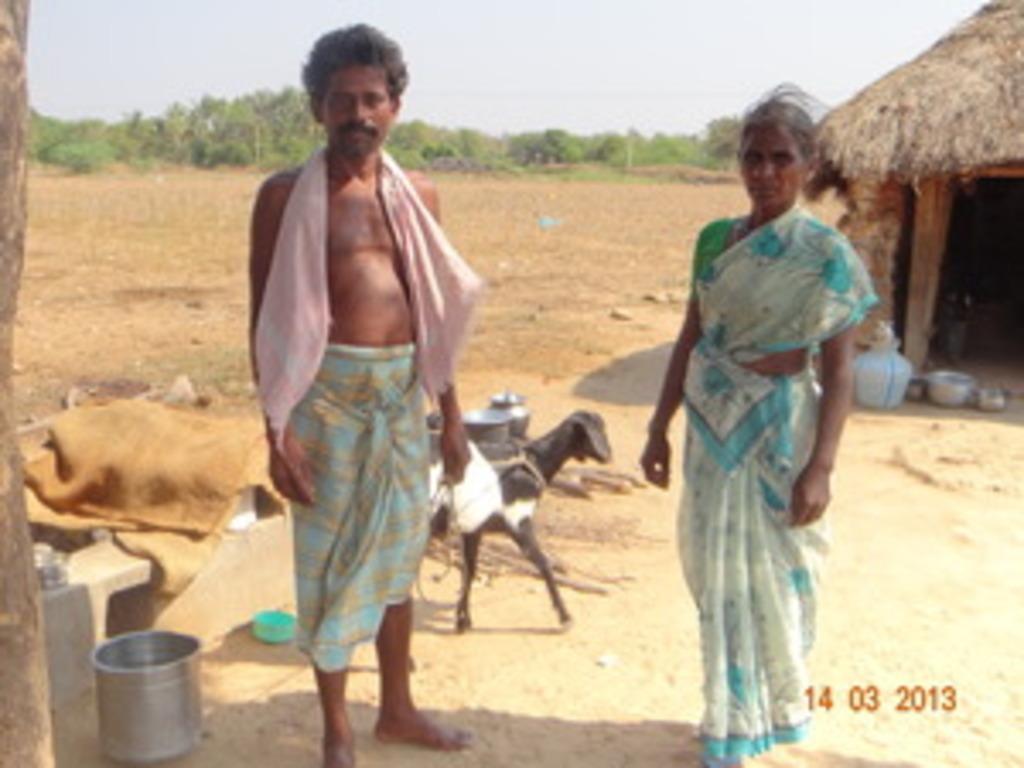Describe this image in one or two sentences. In the image there are two people standing in the foreground and behind them there is a goat, vessels, hut, empty land and in the background there are trees. 